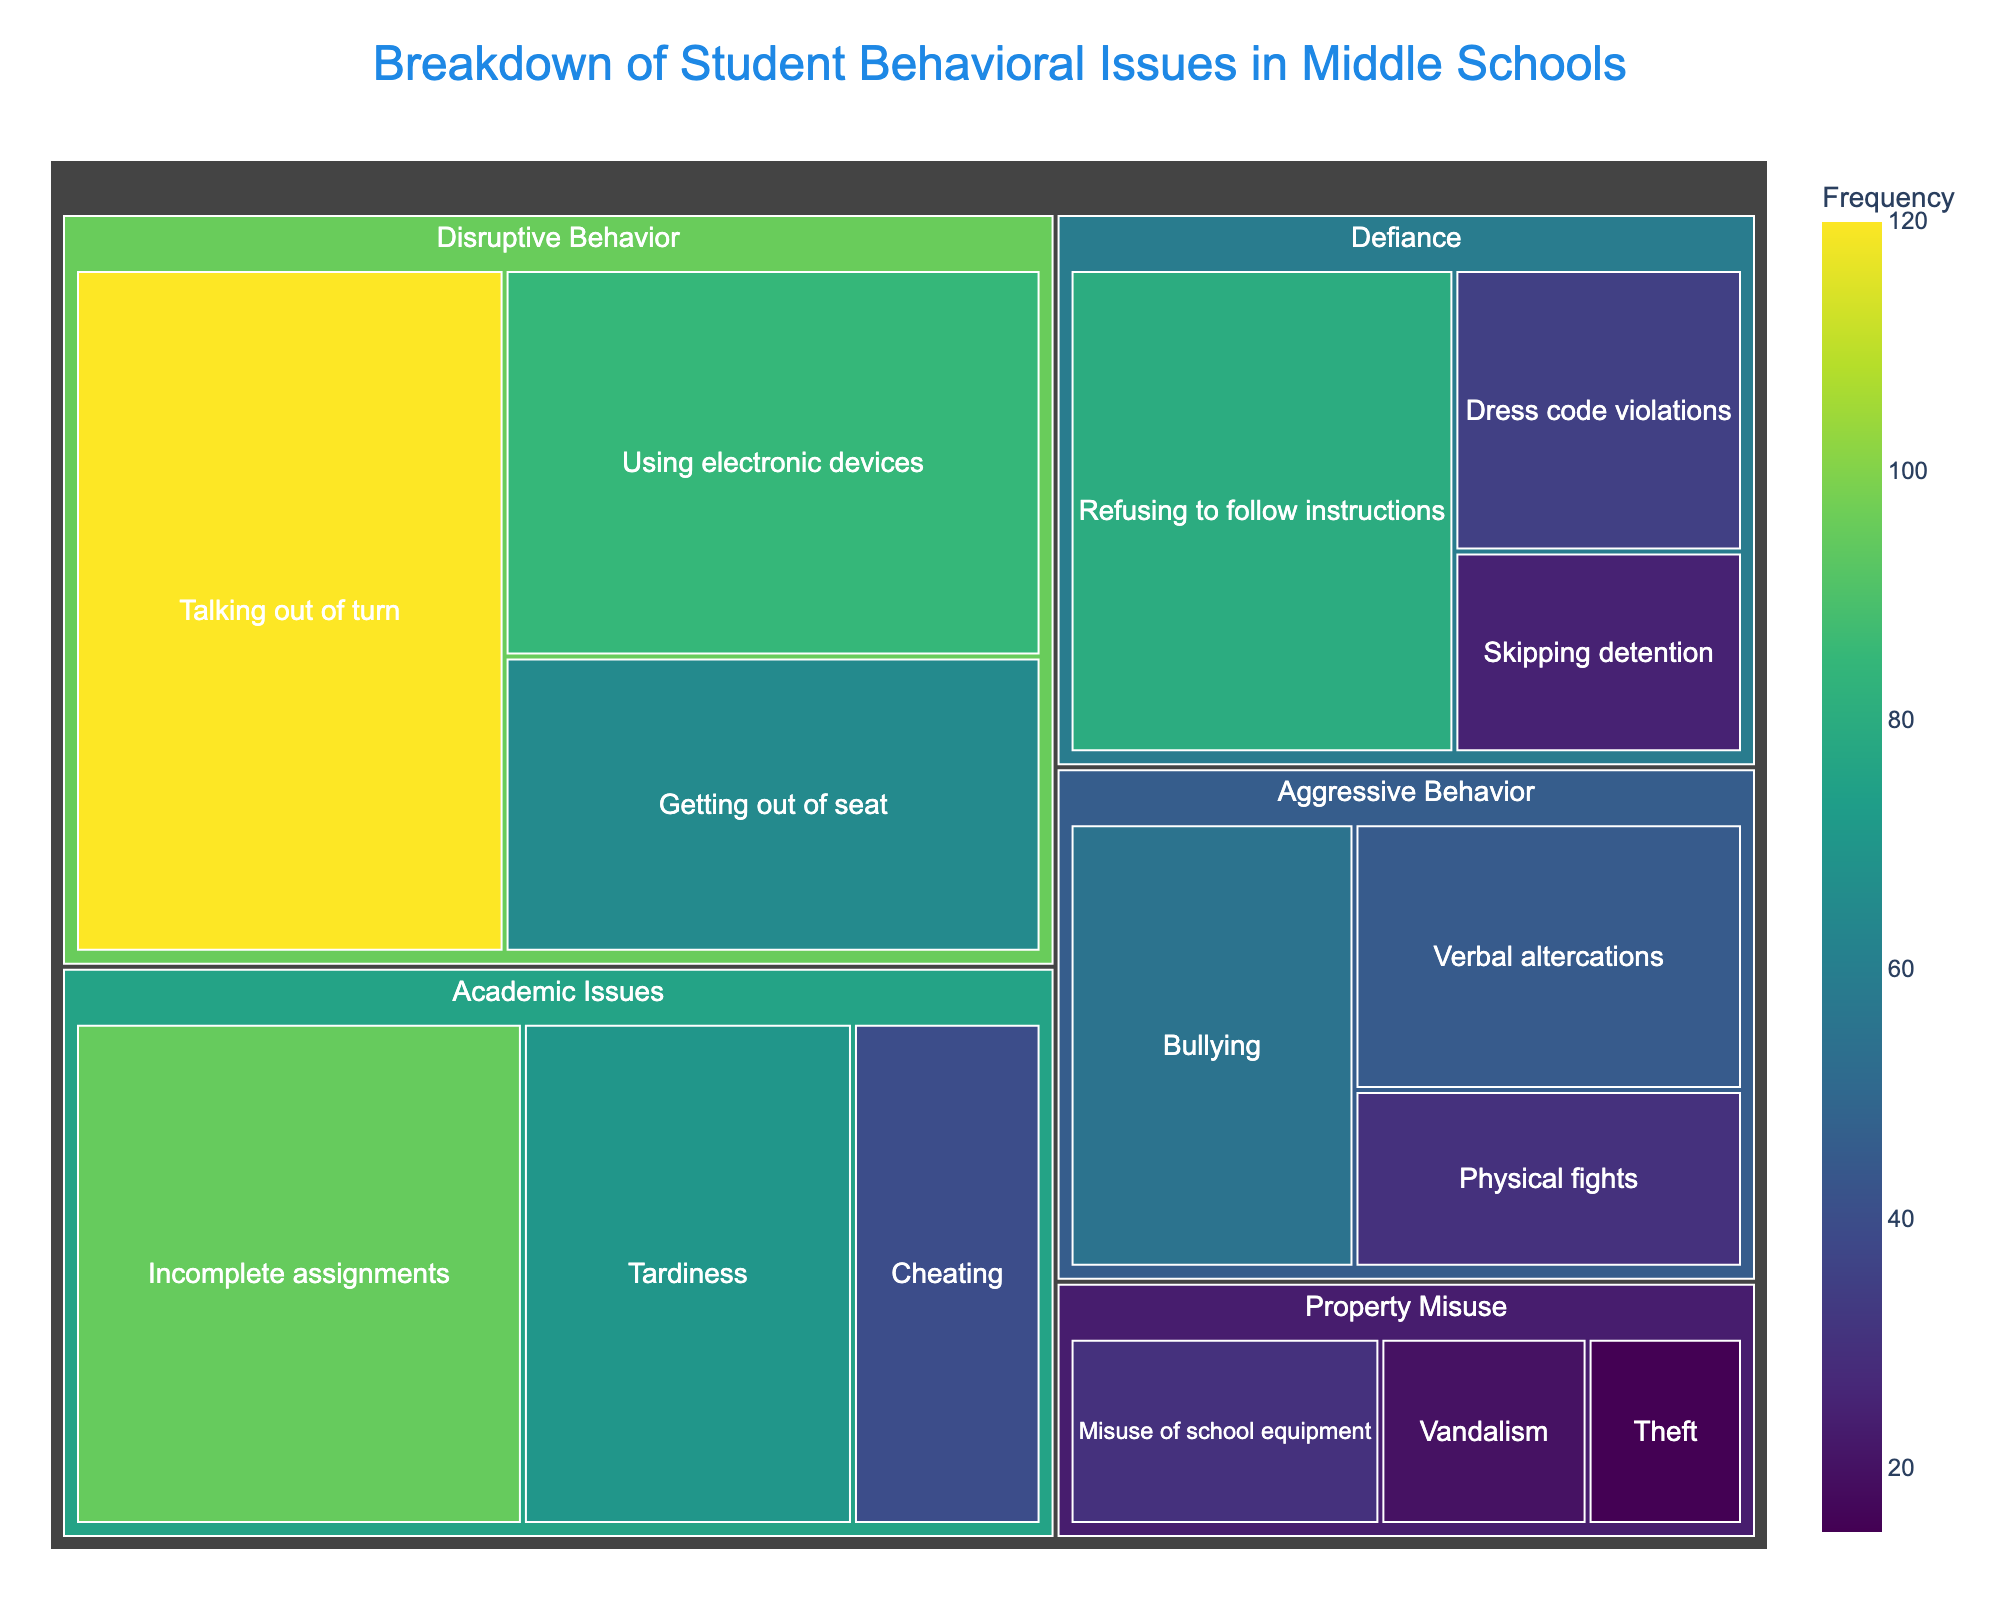What is the title of the chart? The title is shown at the top of the chart.
Answer: Breakdown of Student Behavioral Issues in Middle Schools Which subcategory has the highest frequency? Check the size and color intensity of each subcategory. 'Talking out of turn' will have the largest area with the darkest color.
Answer: Talking out of turn How many subcategories fall under 'Defiance'? Count the number of subcategory rectangles within the 'Defiance' category.
Answer: 3 What is the total frequency of issues classified under 'Aggressive Behavior'? Add up the frequencies of 'Verbal altercations', 'Physical fights', and 'Bullying': 45 + 30 + 55.
Answer: 130 Which category has the least reported frequency, and what is the total frequency? Compare the total frequencies of all categories by summing their subcategories. 'Property Misuse' has the least frequency: 20 + 15 + 30.
Answer: Property Misuse, 65 How much higher is the frequency of 'Incomplete assignments' compared to 'Cheating'? Subtract the frequency of 'Cheating' from 'Incomplete assignments': 95 - 40.
Answer: 55 Which subcategory in 'Property Misuse' has the highest frequency? Look at the frequencies within 'Property Misuse'. 'Misuse of school equipment' has the highest number.
Answer: Misuse of school equipment Are there more instances of 'Tardiness' or 'Refusing to follow instructions'? Compare the frequencies of the two subcategories. 'Refusing to follow instructions' has 80, while 'Tardiness' has 70, so 'Refusing to follow instructions' is higher.
Answer: Refusing to follow instructions What is the average frequency of the subcategories under 'Disruptive Behavior'? Sum the frequencies of the subcategories and then divide by the number of subcategories: (120 + 85 + 65) / 3.
Answer: 90 